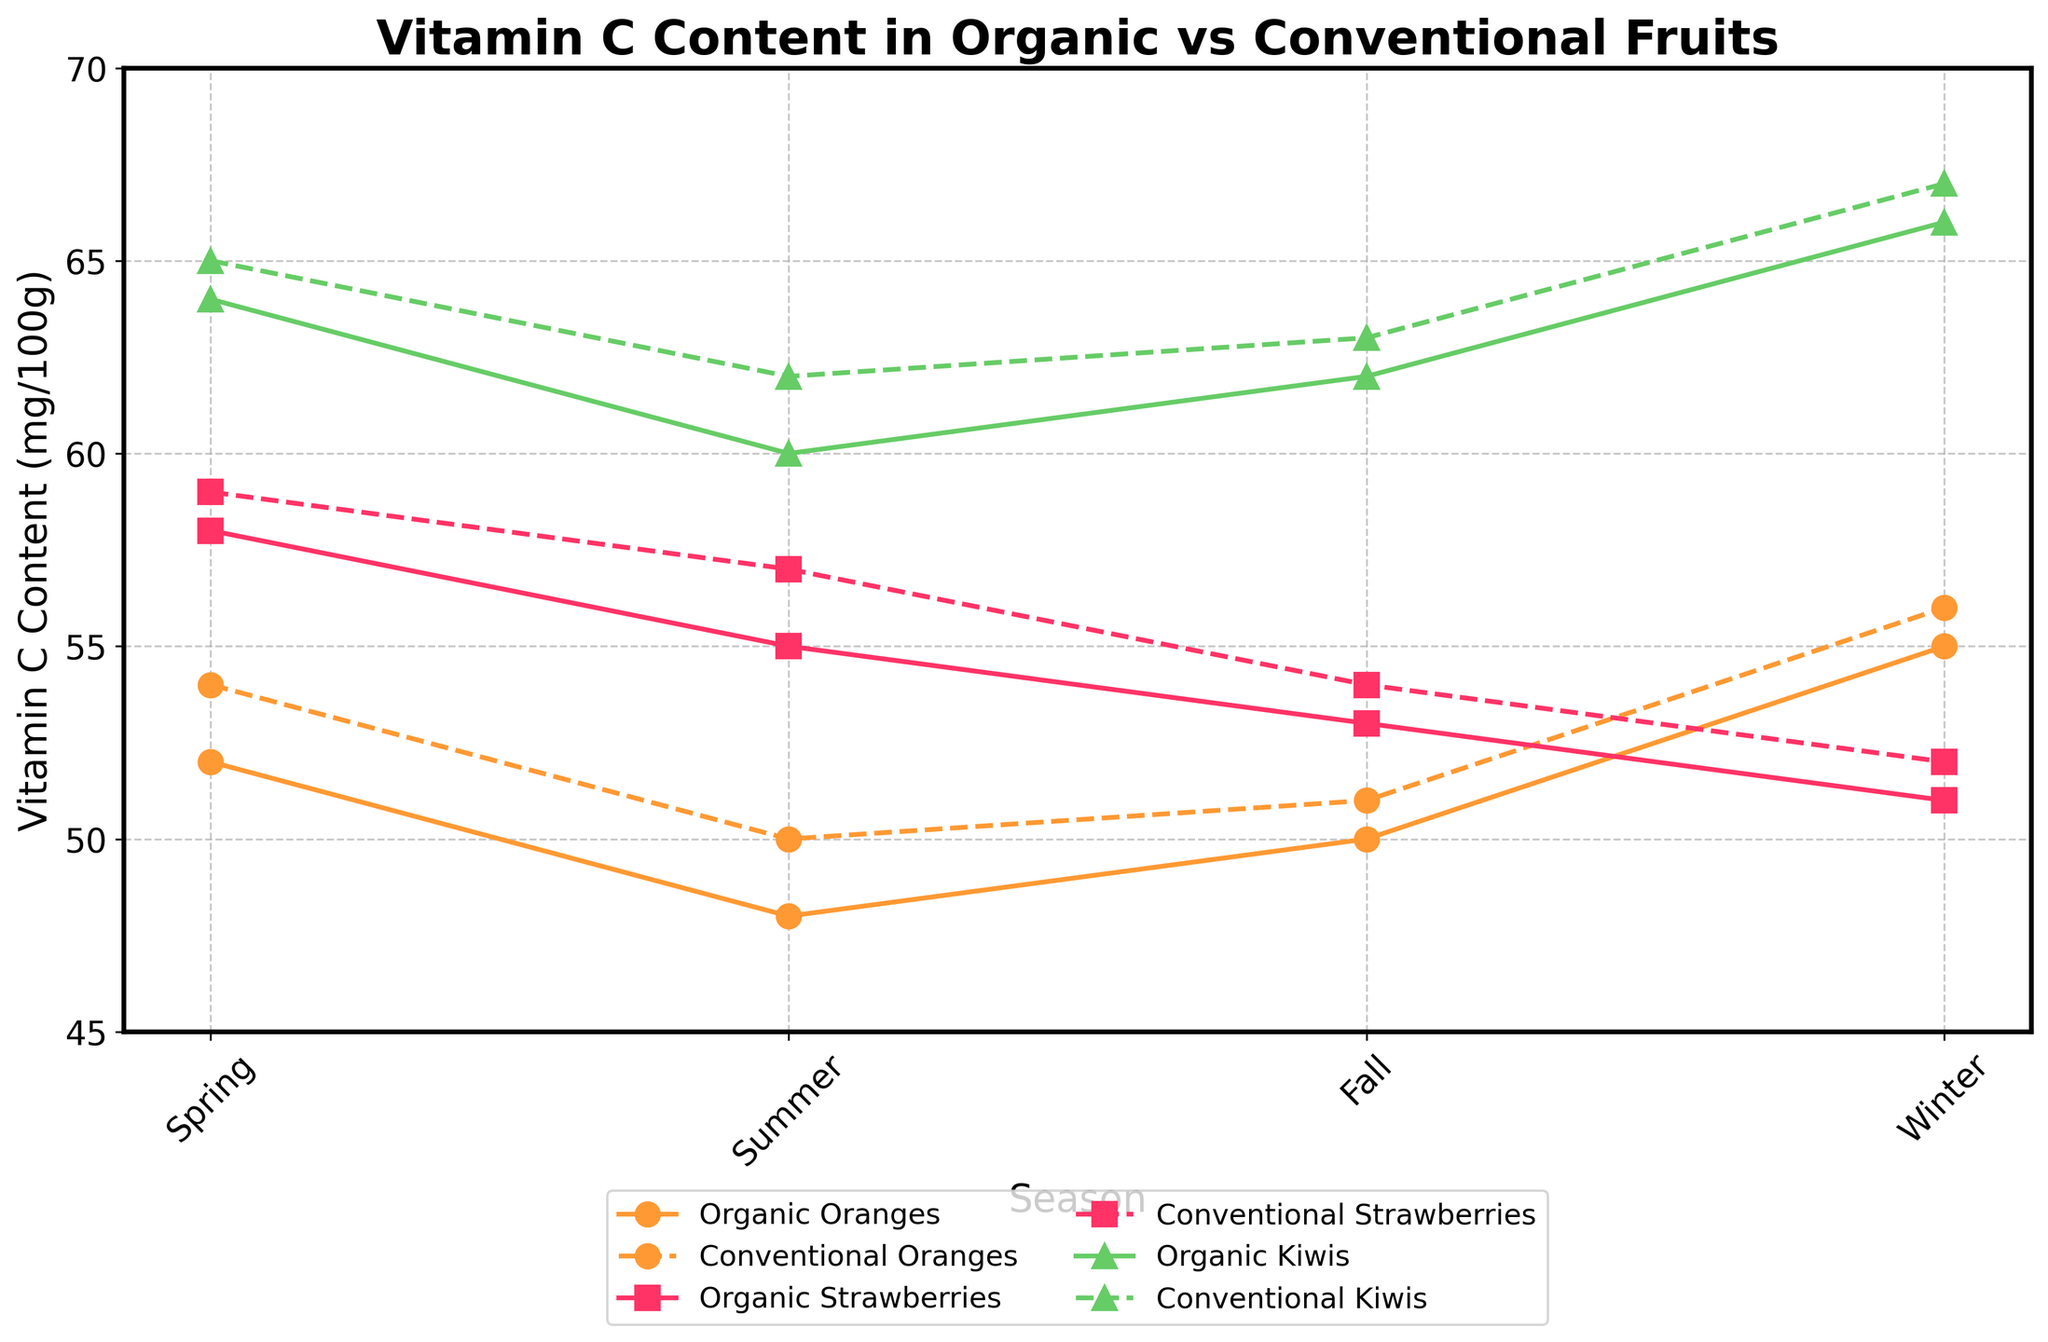How does the vitamin C content of organic oranges in winter compare to that of conventional oranges in the same season? The line chart shows the vitamin C content for different fruits in different seasons. In winter, the vitamin C content for organic oranges is 55 mg/100g, while it is 56 mg/100g for conventional oranges.
Answer: Conventional oranges have slightly higher vitamin C content in winter Which fruit shows the least difference in vitamin C content between its organic and conventional varieties during fall? Looking at the fall data points, organic kiwis have 62 mg/100g and conventional kiwis have 63 mg/100g, resulting in a difference of 1 mg/100g. For strawberries, the difference is 1 mg/100g as well (53 mg/100g for organic and 54 mg/100g for conventional strawberries).
Answer: Kiwis and strawberries both show the least difference with just 1 mg/100g What's the average vitamin C content of conventional strawberries across all seasons? Add the vitamin C content of conventional strawberries for all seasons (59 + 57 + 54 + 52) and divide by 4: (59 + 57 + 54 + 52) / 4 = 55.5 mg/100g.
Answer: 55.5 mg/100g Which season shows the highest average vitamin C content across all fruits and types (organic and conventional)? Calculate the average vitamin C content for each season across all fruits and types, then compare the values. Spring: (52 + 54 + 58 + 59 + 64 + 65)/6 = 58.67, Summer: (48 + 50 + 55 + 57 + 60 + 62)/6 = 55.33, Fall: (50 + 51 + 53 + 54 + 62 + 63)/6 = 55.5, Winter: (55 + 56 + 51 + 52 + 66 + 67)/6 = 57.83.
Answer: Spring Is there any season when organic fruits have higher vitamin C content across all types compared to conventional ones? Compare the vitamin C content for each fruit in each season. In every season, at least one conventional fruit has a slightly higher vitamin C content than the organic one.
Answer: No In which season do organic kiwis show the highest vitamin C content? Look at the data points for organic kiwis across all seasons; spring (64 mg/100g), summer (60 mg/100g), fall (62 mg/100g), winter (66 mg/100g).
Answer: Winter How does the vitamin C content of organic strawberries compare to conventional strawberries in summer? Refer to the summer data points for strawberries: organic strawberries have 55 mg/100g, and conventional strawberries have 57 mg/100g.
Answer: Conventional strawberries have higher vitamin C content in summer What is the combined vitamin C content of organic oranges and organic strawberries in spring? Add the vitamin C contents of organic oranges and organic strawberries in spring: 52 + 58 = 110 mg/100g.
Answer: 110 mg/100g Is there a significant difference in vitamin C content between organic and conventional kiwis during summer? Look at the summer values for kiwis: organic (60 mg/100g) and conventional (62 mg/100g). The difference is 2 mg/100g.
Answer: No significant difference 